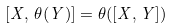<formula> <loc_0><loc_0><loc_500><loc_500>[ X , \, \theta ( Y ) ] = \theta ( [ X , Y ] )</formula> 